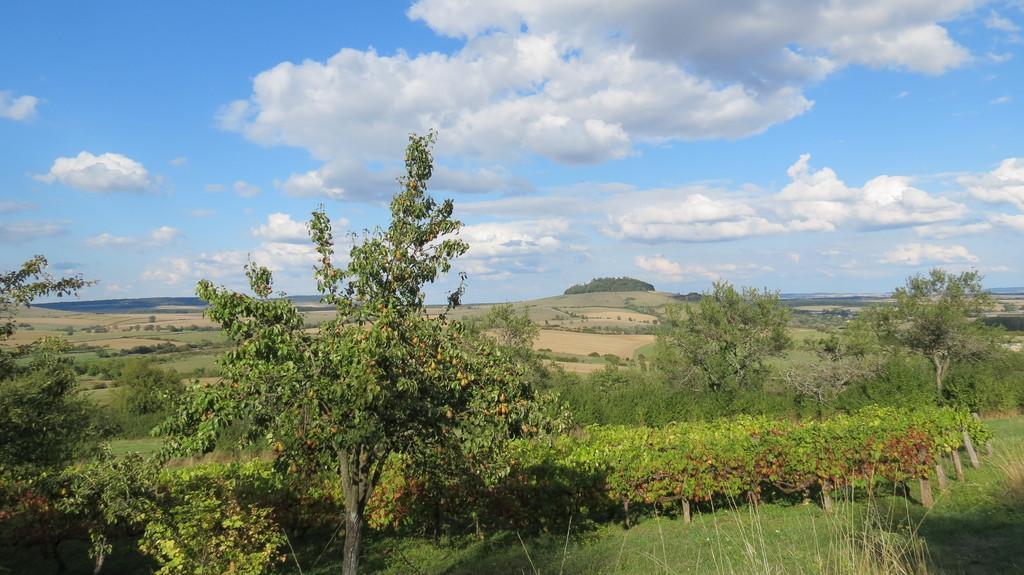Please provide a concise description of this image. In the foreground I can see grass, plants and trees. On the top I can see the sky. This image is taken may be in the forest. 